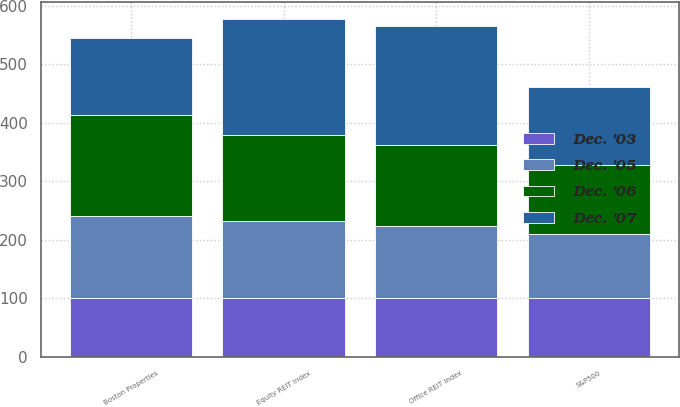<chart> <loc_0><loc_0><loc_500><loc_500><stacked_bar_chart><ecel><fcel>Boston Properties<fcel>S&P500<fcel>Equity REIT Index<fcel>Office REIT Index<nl><fcel>Dec. '03<fcel>100<fcel>100<fcel>100<fcel>100<nl><fcel>Dec. '05<fcel>140.6<fcel>110.87<fcel>131.58<fcel>123.28<nl><fcel>Dec. '06<fcel>173.69<fcel>116.32<fcel>147.59<fcel>139.44<nl><fcel>Dec. '07<fcel>131.58<fcel>134.69<fcel>199.33<fcel>202.5<nl></chart> 